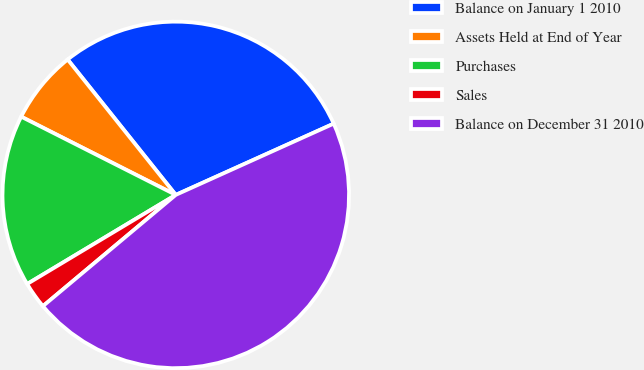<chart> <loc_0><loc_0><loc_500><loc_500><pie_chart><fcel>Balance on January 1 2010<fcel>Assets Held at End of Year<fcel>Purchases<fcel>Sales<fcel>Balance on December 31 2010<nl><fcel>28.98%<fcel>6.82%<fcel>16.05%<fcel>2.5%<fcel>45.65%<nl></chart> 